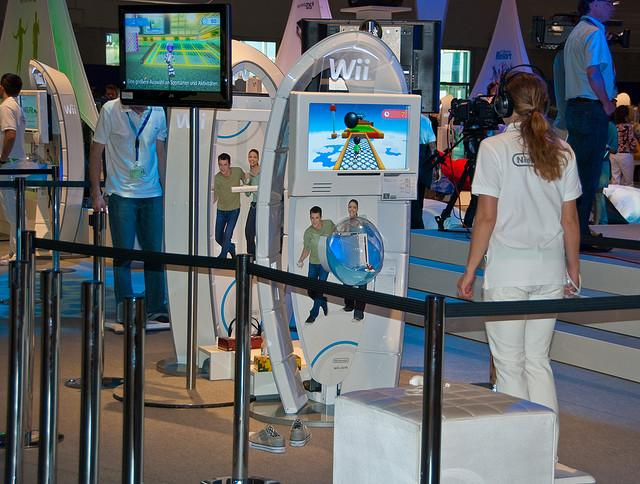What is the article of clothing at the base of the console used for? walking 